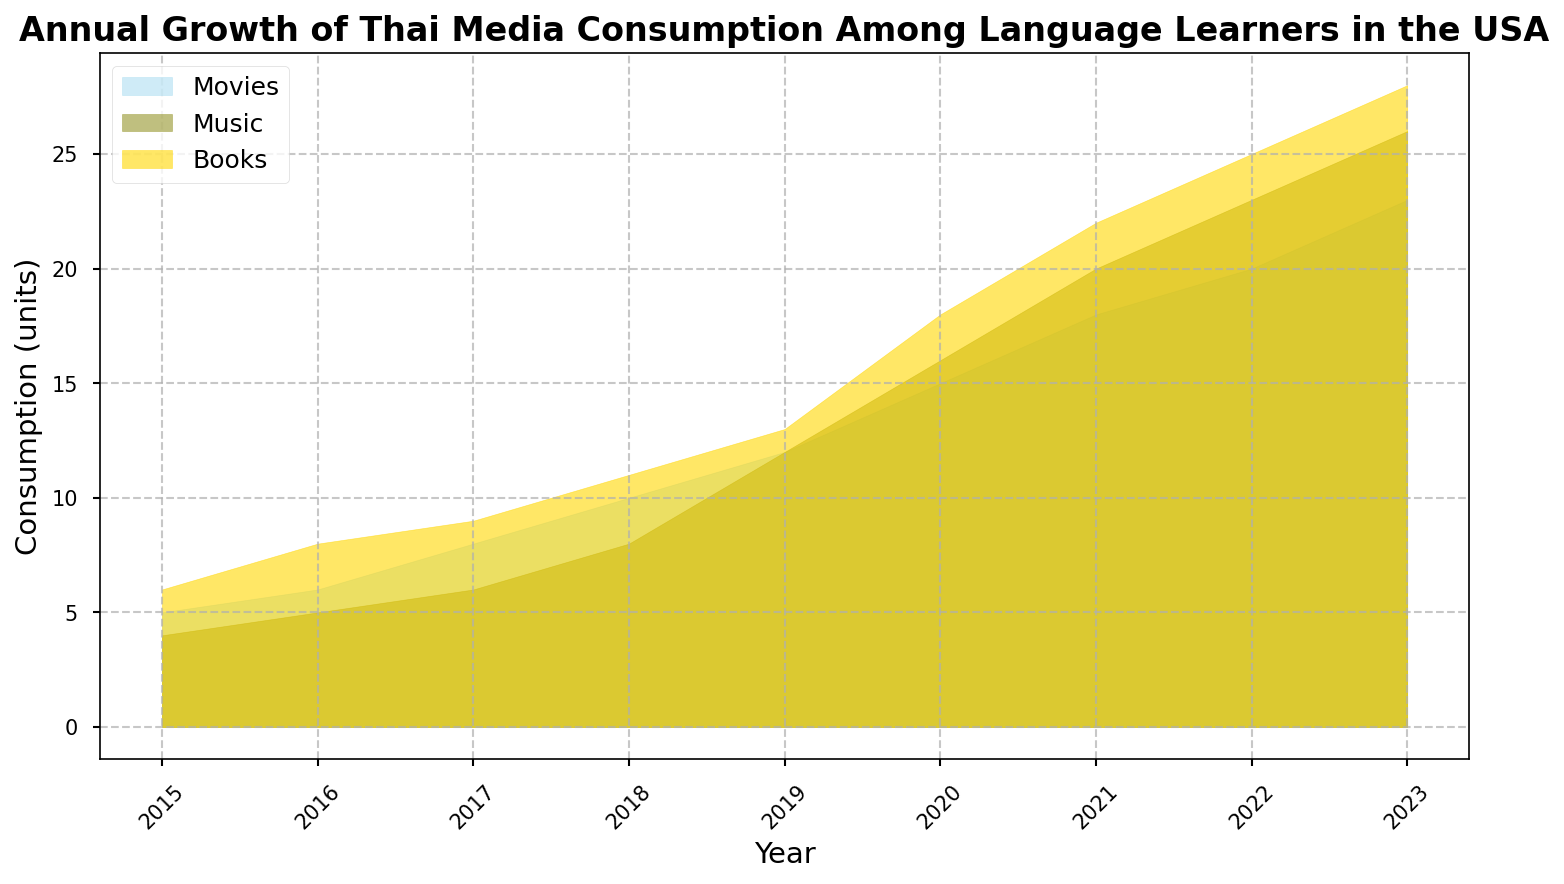What is the trend of Thai music consumption from 2015 to 2023? Visually we can see that the area representing music consumption is growing, with a notable steady increase over the years.
Answer: Increasing Which year had the highest consumption of Thai books? From the chart, the peak of the area representing book consumption occurs in 2023.
Answer: 2023 Compare the rates of growth between movies and music from 2015 to 2020. Which one grew faster? In 2015, movie consumption starts at 5 and grows to 15 by 2020, whereas music consumption starts at 4 and grows to 16 by 2020. Movies increased by 10 units while music increased by 12 units, hence music grew faster.
Answer: Music In 2018, which medium had the lowest consumption among movies, music, and books? For the year 2018, visually inspecting the area chart, the consumption of movies (10) is lower than that of both music (8) and books (11).
Answer: Movies What was the combined consumption of Thai media (movies, music, books) in 2017? Adding the values for each medium in 2017: movies (8) + music (6) + books (9) = 23 units.
Answer: 23 units By how much did the consumption of Thai movies increase from 2015 to 2023? Subtracting the consumption value of movies in 2015 (5) from that in 2023 (23): 23 - 5 = 18 units.
Answer: 18 units During which two consecutive years did Thai music consumption see the largest increase? Observing the differences year by year, the increase is most substantial between 2018 (8) and 2019 (12), resulting in an increase of 4 units.
Answer: 2018-2019 What is the average annual increase in Thai book consumption from 2015 to 2023? The total increase is from 6 in 2015 to 28 in 2023, which is 22 units over 8 years: 22/8 = 2.75 units/year.
Answer: 2.75 units/year 